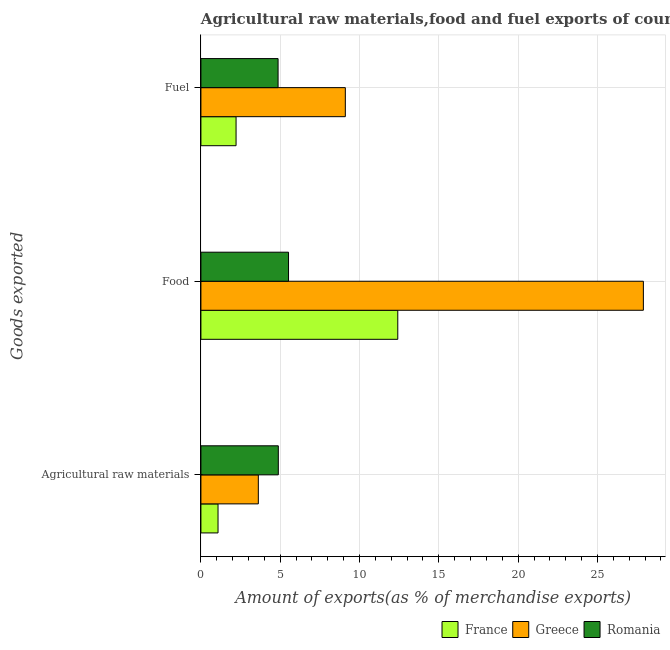How many different coloured bars are there?
Give a very brief answer. 3. How many groups of bars are there?
Your response must be concise. 3. Are the number of bars per tick equal to the number of legend labels?
Make the answer very short. Yes. How many bars are there on the 3rd tick from the top?
Offer a terse response. 3. How many bars are there on the 2nd tick from the bottom?
Your answer should be compact. 3. What is the label of the 3rd group of bars from the top?
Make the answer very short. Agricultural raw materials. What is the percentage of food exports in Romania?
Offer a terse response. 5.52. Across all countries, what is the maximum percentage of fuel exports?
Keep it short and to the point. 9.1. Across all countries, what is the minimum percentage of fuel exports?
Offer a terse response. 2.22. In which country was the percentage of food exports minimum?
Your answer should be compact. Romania. What is the total percentage of raw materials exports in the graph?
Make the answer very short. 9.58. What is the difference between the percentage of fuel exports in Romania and that in Greece?
Your answer should be compact. -4.24. What is the difference between the percentage of raw materials exports in Greece and the percentage of food exports in Romania?
Ensure brevity in your answer.  -1.9. What is the average percentage of raw materials exports per country?
Ensure brevity in your answer.  3.19. What is the difference between the percentage of raw materials exports and percentage of fuel exports in Romania?
Keep it short and to the point. 0.01. What is the ratio of the percentage of food exports in Romania to that in France?
Provide a succinct answer. 0.45. Is the percentage of fuel exports in Greece less than that in France?
Provide a succinct answer. No. Is the difference between the percentage of raw materials exports in France and Greece greater than the difference between the percentage of fuel exports in France and Greece?
Make the answer very short. Yes. What is the difference between the highest and the second highest percentage of raw materials exports?
Your answer should be compact. 1.26. What is the difference between the highest and the lowest percentage of raw materials exports?
Offer a very short reply. 3.8. What does the 1st bar from the top in Agricultural raw materials represents?
Your answer should be compact. Romania. What does the 3rd bar from the bottom in Fuel represents?
Provide a succinct answer. Romania. How many bars are there?
Your answer should be very brief. 9. What is the difference between two consecutive major ticks on the X-axis?
Your answer should be compact. 5. Does the graph contain any zero values?
Ensure brevity in your answer.  No. What is the title of the graph?
Offer a terse response. Agricultural raw materials,food and fuel exports of countries in 1999. What is the label or title of the X-axis?
Your answer should be compact. Amount of exports(as % of merchandise exports). What is the label or title of the Y-axis?
Offer a very short reply. Goods exported. What is the Amount of exports(as % of merchandise exports) of France in Agricultural raw materials?
Offer a terse response. 1.08. What is the Amount of exports(as % of merchandise exports) in Greece in Agricultural raw materials?
Your answer should be compact. 3.62. What is the Amount of exports(as % of merchandise exports) of Romania in Agricultural raw materials?
Keep it short and to the point. 4.88. What is the Amount of exports(as % of merchandise exports) of France in Food?
Keep it short and to the point. 12.41. What is the Amount of exports(as % of merchandise exports) in Greece in Food?
Your response must be concise. 27.9. What is the Amount of exports(as % of merchandise exports) in Romania in Food?
Your response must be concise. 5.52. What is the Amount of exports(as % of merchandise exports) in France in Fuel?
Offer a terse response. 2.22. What is the Amount of exports(as % of merchandise exports) in Greece in Fuel?
Make the answer very short. 9.1. What is the Amount of exports(as % of merchandise exports) of Romania in Fuel?
Provide a succinct answer. 4.86. Across all Goods exported, what is the maximum Amount of exports(as % of merchandise exports) in France?
Ensure brevity in your answer.  12.41. Across all Goods exported, what is the maximum Amount of exports(as % of merchandise exports) of Greece?
Your answer should be very brief. 27.9. Across all Goods exported, what is the maximum Amount of exports(as % of merchandise exports) in Romania?
Offer a terse response. 5.52. Across all Goods exported, what is the minimum Amount of exports(as % of merchandise exports) in France?
Offer a very short reply. 1.08. Across all Goods exported, what is the minimum Amount of exports(as % of merchandise exports) in Greece?
Your answer should be compact. 3.62. Across all Goods exported, what is the minimum Amount of exports(as % of merchandise exports) of Romania?
Give a very brief answer. 4.86. What is the total Amount of exports(as % of merchandise exports) of France in the graph?
Ensure brevity in your answer.  15.71. What is the total Amount of exports(as % of merchandise exports) of Greece in the graph?
Make the answer very short. 40.62. What is the total Amount of exports(as % of merchandise exports) in Romania in the graph?
Keep it short and to the point. 15.27. What is the difference between the Amount of exports(as % of merchandise exports) of France in Agricultural raw materials and that in Food?
Your answer should be compact. -11.33. What is the difference between the Amount of exports(as % of merchandise exports) in Greece in Agricultural raw materials and that in Food?
Provide a succinct answer. -24.28. What is the difference between the Amount of exports(as % of merchandise exports) of Romania in Agricultural raw materials and that in Food?
Offer a very short reply. -0.64. What is the difference between the Amount of exports(as % of merchandise exports) in France in Agricultural raw materials and that in Fuel?
Give a very brief answer. -1.14. What is the difference between the Amount of exports(as % of merchandise exports) in Greece in Agricultural raw materials and that in Fuel?
Ensure brevity in your answer.  -5.49. What is the difference between the Amount of exports(as % of merchandise exports) in Romania in Agricultural raw materials and that in Fuel?
Your answer should be compact. 0.01. What is the difference between the Amount of exports(as % of merchandise exports) of France in Food and that in Fuel?
Give a very brief answer. 10.2. What is the difference between the Amount of exports(as % of merchandise exports) in Greece in Food and that in Fuel?
Provide a short and direct response. 18.79. What is the difference between the Amount of exports(as % of merchandise exports) of Romania in Food and that in Fuel?
Your response must be concise. 0.66. What is the difference between the Amount of exports(as % of merchandise exports) in France in Agricultural raw materials and the Amount of exports(as % of merchandise exports) in Greece in Food?
Provide a short and direct response. -26.82. What is the difference between the Amount of exports(as % of merchandise exports) of France in Agricultural raw materials and the Amount of exports(as % of merchandise exports) of Romania in Food?
Provide a succinct answer. -4.44. What is the difference between the Amount of exports(as % of merchandise exports) in Greece in Agricultural raw materials and the Amount of exports(as % of merchandise exports) in Romania in Food?
Your answer should be compact. -1.9. What is the difference between the Amount of exports(as % of merchandise exports) of France in Agricultural raw materials and the Amount of exports(as % of merchandise exports) of Greece in Fuel?
Your answer should be compact. -8.03. What is the difference between the Amount of exports(as % of merchandise exports) in France in Agricultural raw materials and the Amount of exports(as % of merchandise exports) in Romania in Fuel?
Provide a succinct answer. -3.79. What is the difference between the Amount of exports(as % of merchandise exports) in Greece in Agricultural raw materials and the Amount of exports(as % of merchandise exports) in Romania in Fuel?
Offer a terse response. -1.25. What is the difference between the Amount of exports(as % of merchandise exports) in France in Food and the Amount of exports(as % of merchandise exports) in Greece in Fuel?
Your answer should be very brief. 3.31. What is the difference between the Amount of exports(as % of merchandise exports) of France in Food and the Amount of exports(as % of merchandise exports) of Romania in Fuel?
Offer a terse response. 7.55. What is the difference between the Amount of exports(as % of merchandise exports) of Greece in Food and the Amount of exports(as % of merchandise exports) of Romania in Fuel?
Your answer should be very brief. 23.03. What is the average Amount of exports(as % of merchandise exports) in France per Goods exported?
Provide a succinct answer. 5.24. What is the average Amount of exports(as % of merchandise exports) in Greece per Goods exported?
Give a very brief answer. 13.54. What is the average Amount of exports(as % of merchandise exports) in Romania per Goods exported?
Give a very brief answer. 5.09. What is the difference between the Amount of exports(as % of merchandise exports) in France and Amount of exports(as % of merchandise exports) in Greece in Agricultural raw materials?
Offer a terse response. -2.54. What is the difference between the Amount of exports(as % of merchandise exports) of France and Amount of exports(as % of merchandise exports) of Romania in Agricultural raw materials?
Your answer should be very brief. -3.8. What is the difference between the Amount of exports(as % of merchandise exports) in Greece and Amount of exports(as % of merchandise exports) in Romania in Agricultural raw materials?
Provide a short and direct response. -1.26. What is the difference between the Amount of exports(as % of merchandise exports) of France and Amount of exports(as % of merchandise exports) of Greece in Food?
Keep it short and to the point. -15.48. What is the difference between the Amount of exports(as % of merchandise exports) of France and Amount of exports(as % of merchandise exports) of Romania in Food?
Give a very brief answer. 6.89. What is the difference between the Amount of exports(as % of merchandise exports) of Greece and Amount of exports(as % of merchandise exports) of Romania in Food?
Provide a succinct answer. 22.37. What is the difference between the Amount of exports(as % of merchandise exports) in France and Amount of exports(as % of merchandise exports) in Greece in Fuel?
Ensure brevity in your answer.  -6.89. What is the difference between the Amount of exports(as % of merchandise exports) in France and Amount of exports(as % of merchandise exports) in Romania in Fuel?
Your response must be concise. -2.65. What is the difference between the Amount of exports(as % of merchandise exports) of Greece and Amount of exports(as % of merchandise exports) of Romania in Fuel?
Offer a terse response. 4.24. What is the ratio of the Amount of exports(as % of merchandise exports) in France in Agricultural raw materials to that in Food?
Give a very brief answer. 0.09. What is the ratio of the Amount of exports(as % of merchandise exports) of Greece in Agricultural raw materials to that in Food?
Your answer should be compact. 0.13. What is the ratio of the Amount of exports(as % of merchandise exports) of Romania in Agricultural raw materials to that in Food?
Give a very brief answer. 0.88. What is the ratio of the Amount of exports(as % of merchandise exports) of France in Agricultural raw materials to that in Fuel?
Make the answer very short. 0.49. What is the ratio of the Amount of exports(as % of merchandise exports) in Greece in Agricultural raw materials to that in Fuel?
Keep it short and to the point. 0.4. What is the ratio of the Amount of exports(as % of merchandise exports) in France in Food to that in Fuel?
Offer a very short reply. 5.6. What is the ratio of the Amount of exports(as % of merchandise exports) of Greece in Food to that in Fuel?
Your response must be concise. 3.06. What is the ratio of the Amount of exports(as % of merchandise exports) of Romania in Food to that in Fuel?
Keep it short and to the point. 1.14. What is the difference between the highest and the second highest Amount of exports(as % of merchandise exports) in France?
Your answer should be compact. 10.2. What is the difference between the highest and the second highest Amount of exports(as % of merchandise exports) in Greece?
Provide a succinct answer. 18.79. What is the difference between the highest and the second highest Amount of exports(as % of merchandise exports) of Romania?
Provide a succinct answer. 0.64. What is the difference between the highest and the lowest Amount of exports(as % of merchandise exports) of France?
Give a very brief answer. 11.33. What is the difference between the highest and the lowest Amount of exports(as % of merchandise exports) of Greece?
Offer a terse response. 24.28. What is the difference between the highest and the lowest Amount of exports(as % of merchandise exports) in Romania?
Offer a very short reply. 0.66. 